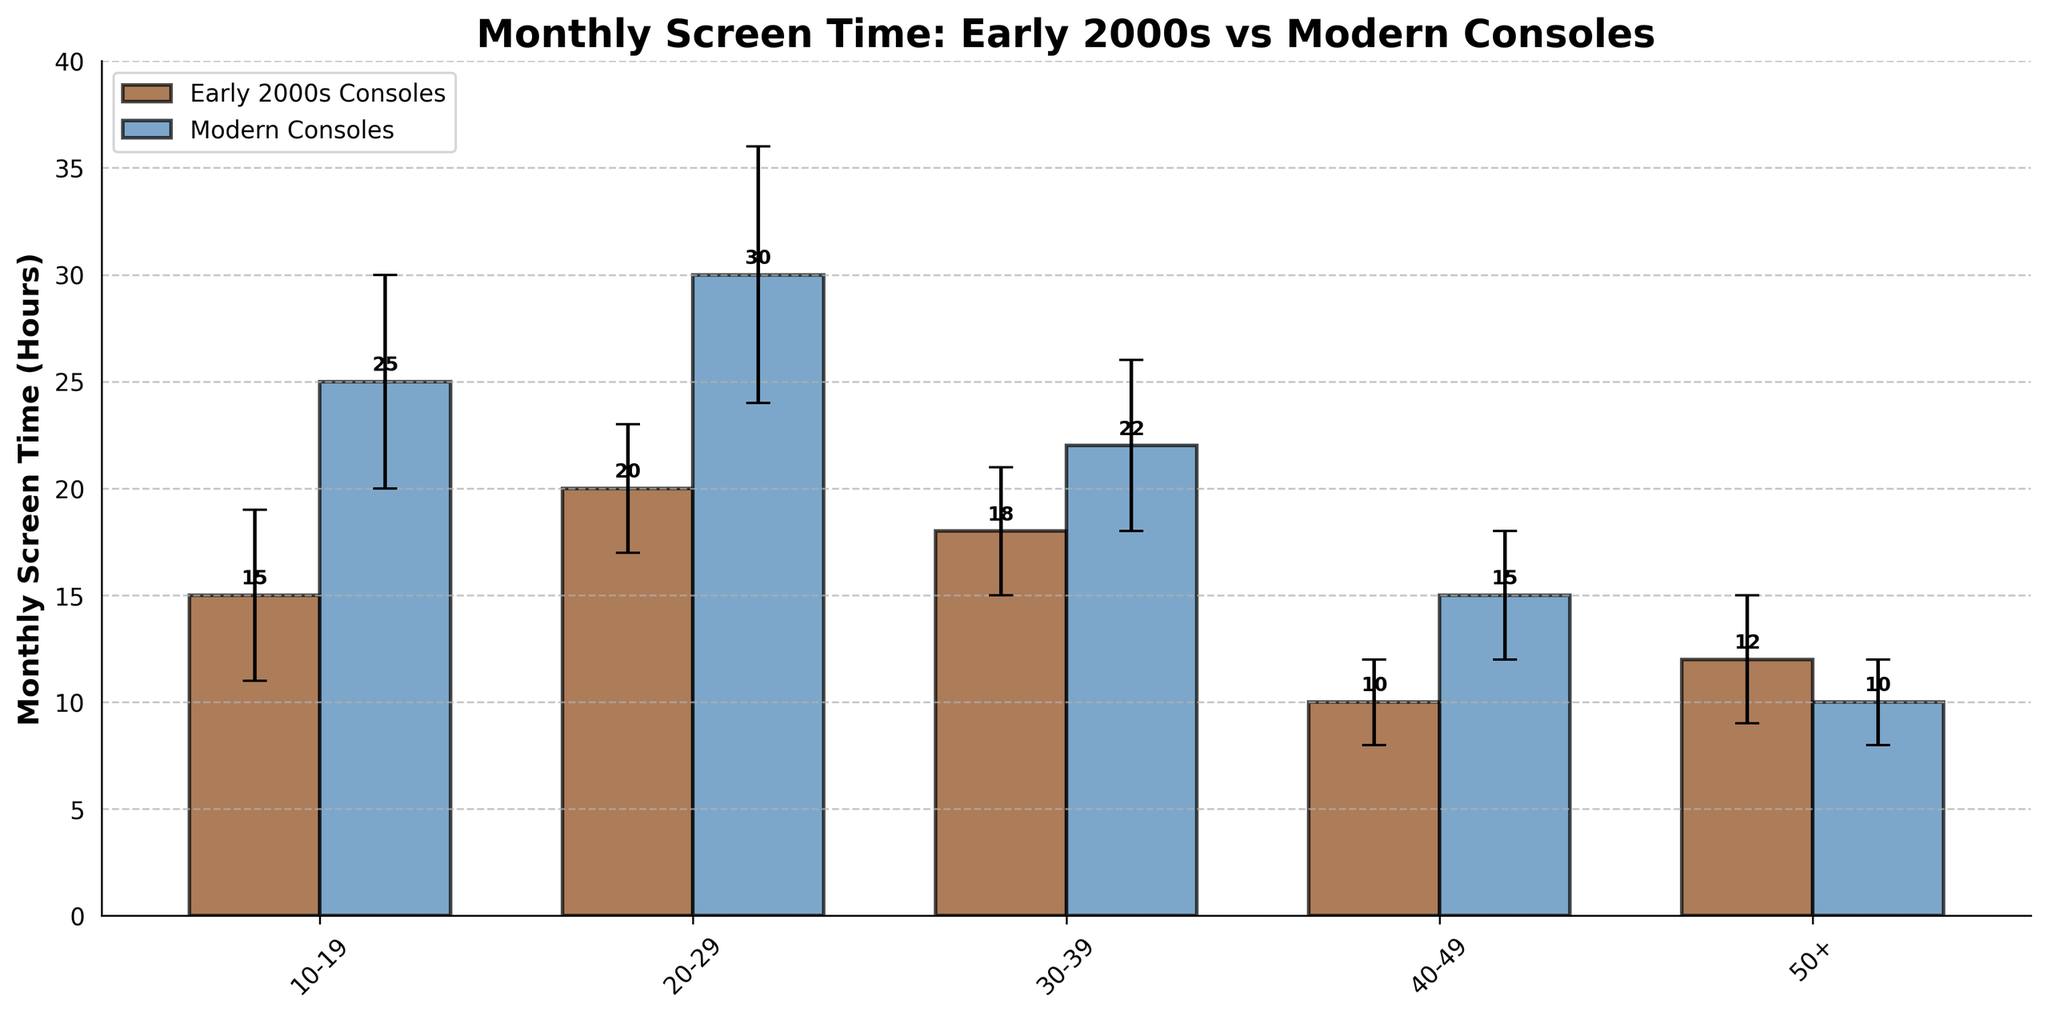What are the two different types of consoles shown in the figure? The title and the legend indicate the two types of consoles shown are "Early 2000s Consoles" and "Modern Consoles".
Answer: Early 2000s Consoles and Modern Consoles Which age group has the highest average monthly screen time for Early 2000s Consoles? Looking at the bars for the Early 2000s Consoles, the age group "20-29" has the tallest bar, indicating the highest average monthly screen time.
Answer: 20-29 By how many hours does the monthly screen time for Modern Consoles exceed that of Early 2000s Consoles for the 10-19 age group? The bar heights for Modern Consoles and Early 2000s Consoles in the 10-19 age group are 25 hours and 15 hours respectively. The difference is 25 - 15 = 10 hours.
Answer: 10 hours What is the standard deviation for the "30-39" age group's screen time in Modern Consoles? The bar for Modern Consoles in the "30-39" age group has an error bar indicating a standard deviation of 4 hours.
Answer: 4 hours Which age group has a lower screen time for Modern Consoles compared to Early 2000s Consoles? By looking at the bars for each age group, the "50+" age group has a lower screen time for Modern Consoles (10 hours) compared to Early 2000s Consoles (12 hours).
Answer: 50+ What is the total monthly screen time for Modern Consoles across all age groups? Sum the monthly screen time for Modern Consoles across all age groups: 25 (10-19) + 30 (20-29) + 22 (30-39) + 15 (40-49) + 10 (50+) = 102 hours.
Answer: 102 hours What age group shows the smallest standard deviation in monthly screen time for Early 2000s Consoles? The error bars indicate the standard deviations: "10-19" (4), "20-29" (3), "30-39" (3), "40-49" (2), and "50+" (3). The smallest standard deviation is 2 hours in the "40-49" age group.
Answer: 40-49 How does the monthly screen time for Early 2000s Consoles compare between the "20-29" and "30-39" age groups? The bars indicate the monthly screen time for Early 2000s Consoles is 20 hours for "20-29" and 18 hours for "30-39". The "20-29" age group has 2 hours more screen time.
Answer: 2 hours more in 20-29 Which age group has the greatest difference in monthly screen time between Early 2000s Consoles and Modern Consoles? Calculate the differences: (10-19): 10, (20-29): 10, (30-39): 4, (40-49): 5, (50+): 2. The age groups "10-19" and "20-29" both have a difference of 10 hours, making them the groups with the greatest difference.
Answer: 10-19 and 20-29 What's the average monthly screen time for Early 2000s Consoles across all age groups? Sum the monthly screen time for Early 2000s Consoles across all age groups: 15 + 20 + 18 + 10 + 12 = 75 hours. Divide by the number of age groups (5): 75 / 5 = 15 hours.
Answer: 15 hours 